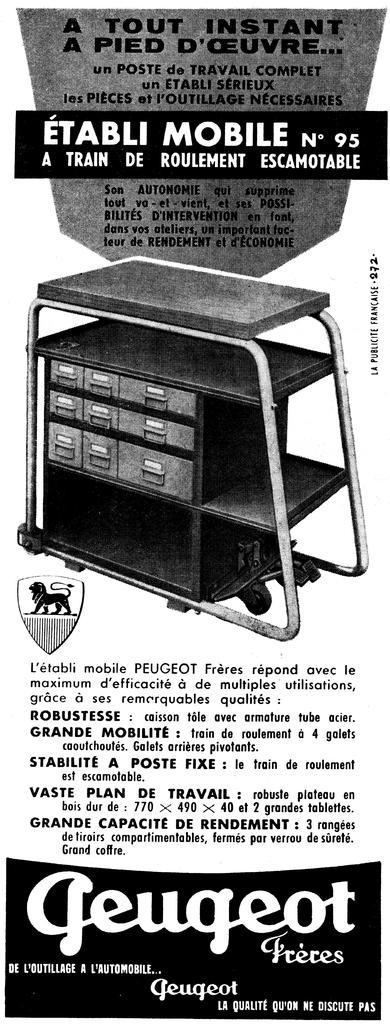<image>
Render a clear and concise summary of the photo. a poster with the name Geugeot on it 